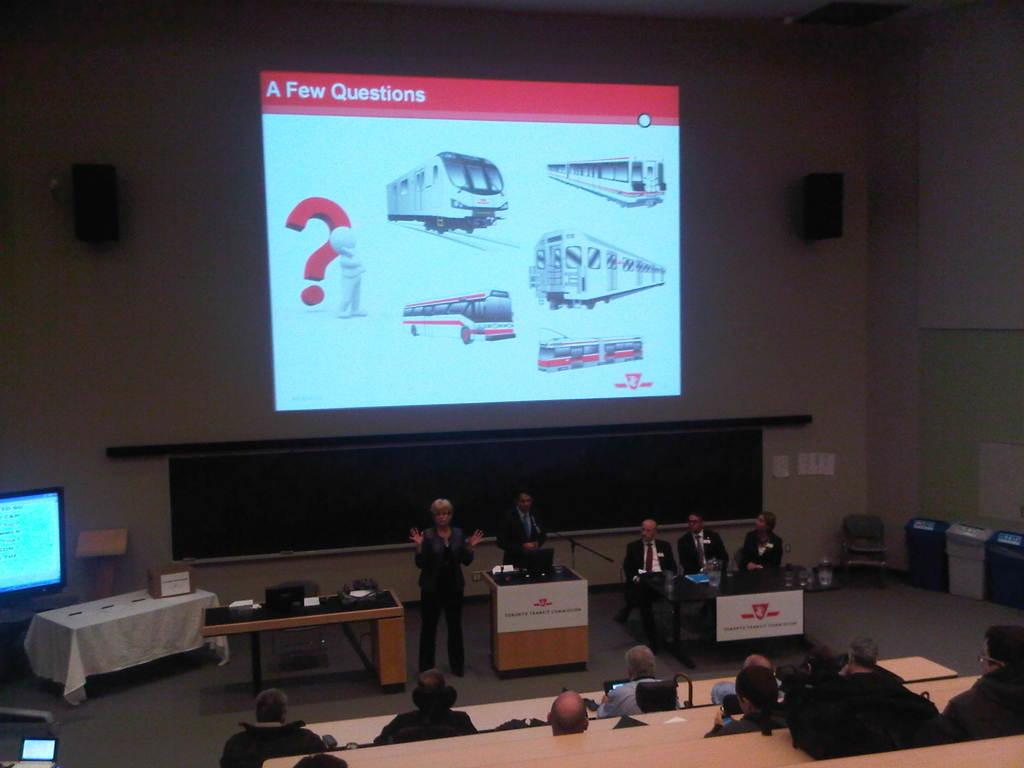Provide a one-sentence caption for the provided image. A press conference with a screen on the wall that says "A Few Questions". 